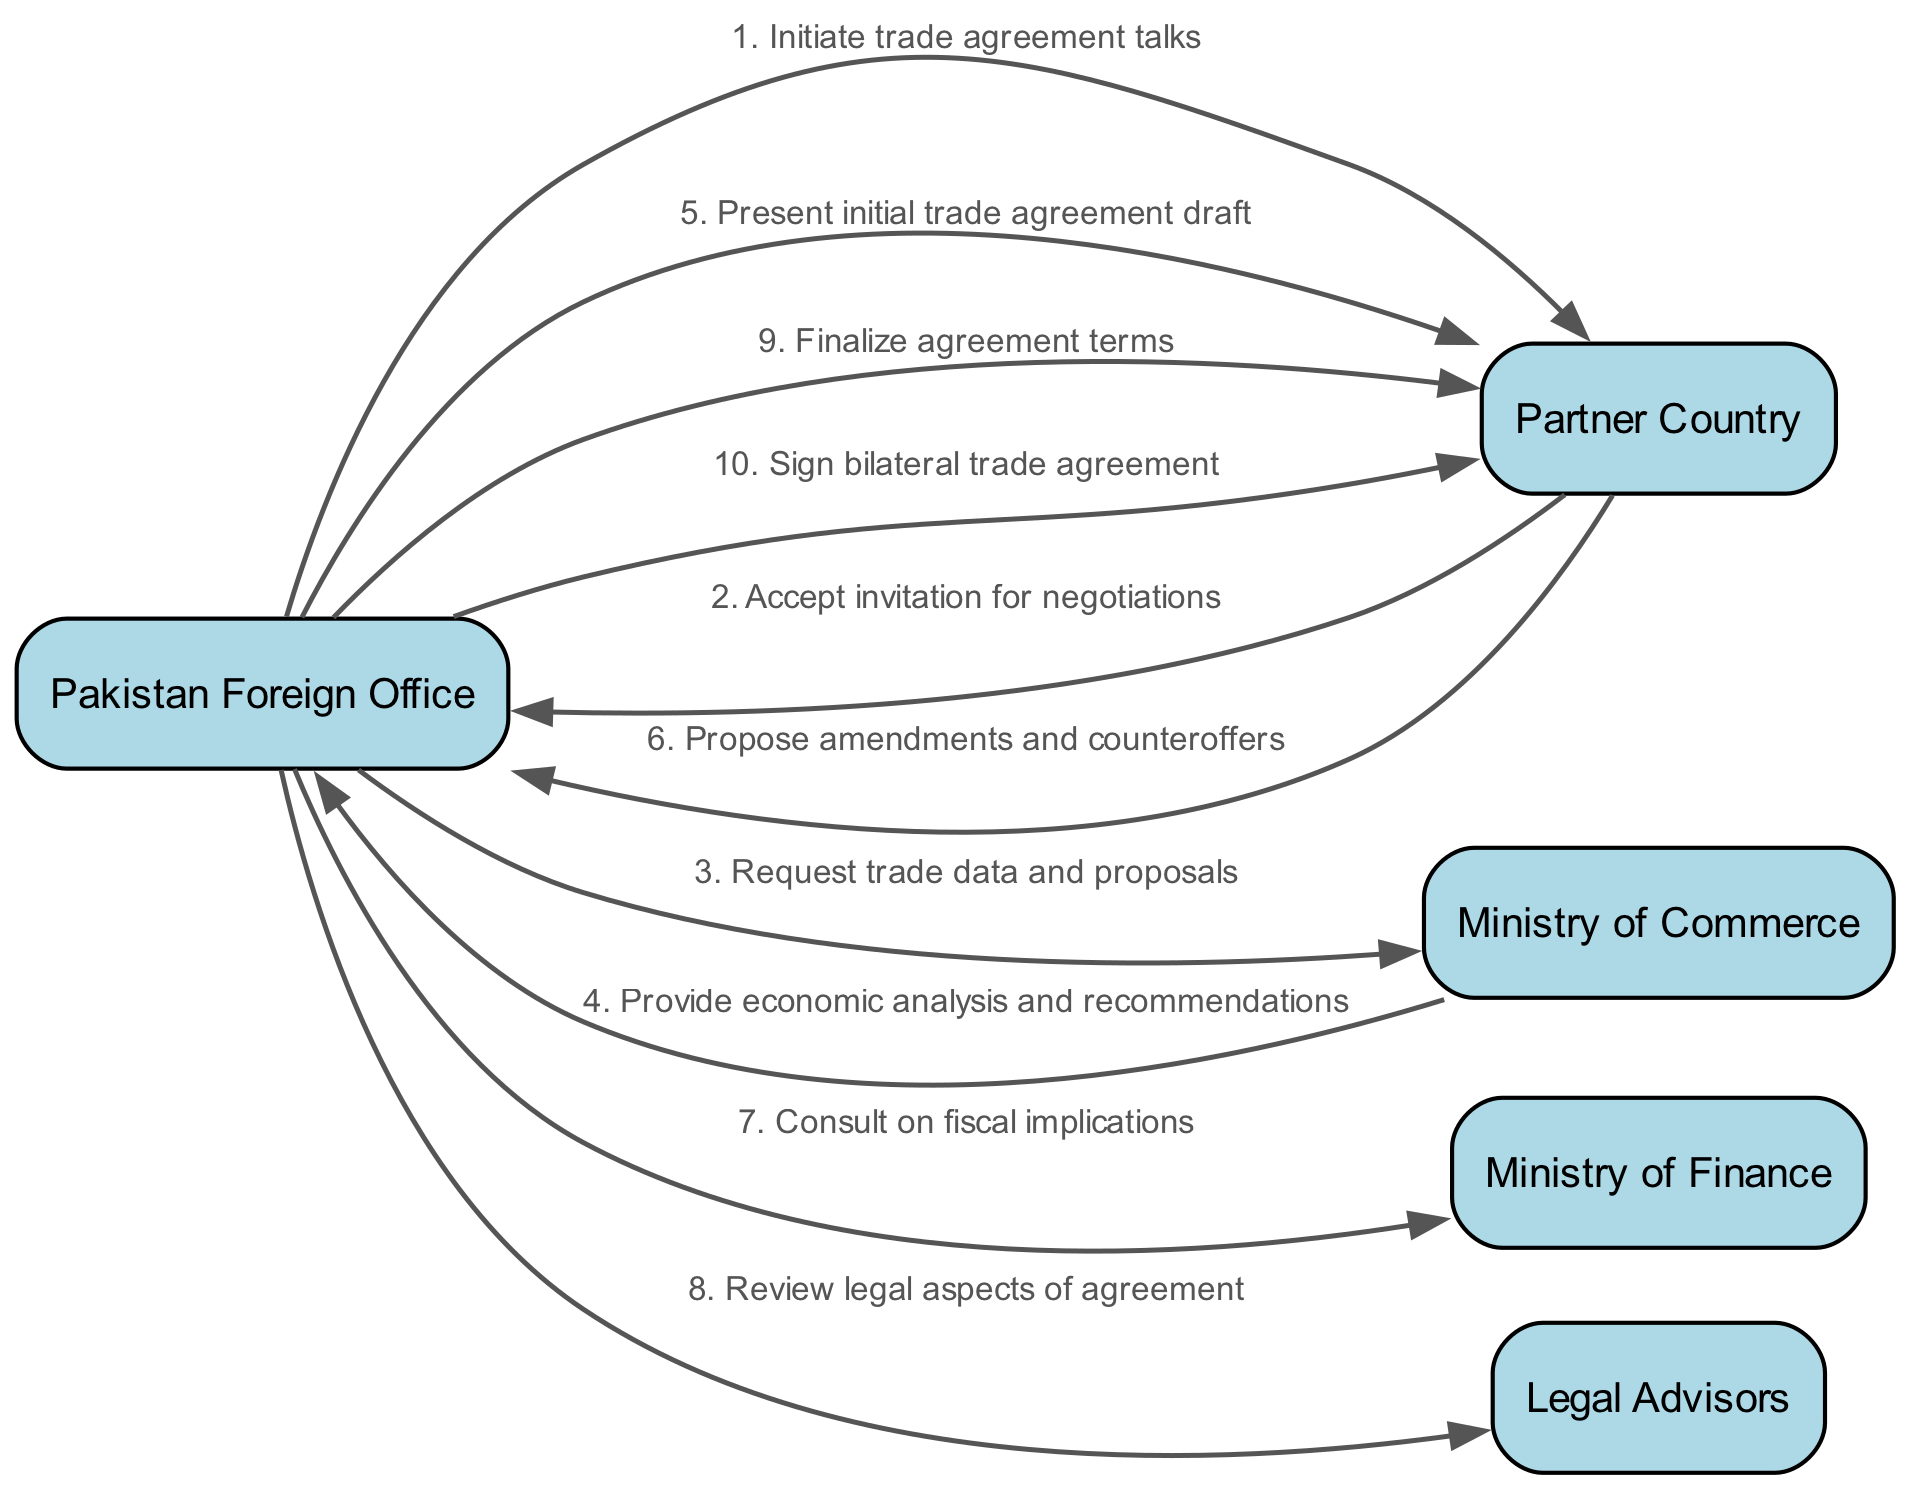What is the first message in the sequence? The first message is from the "Pakistan Foreign Office" to the "Partner Country" with the message "Initiate trade agreement talks".
Answer: Initiate trade agreement talks How many actors are involved in the negotiation process? The diagram lists five distinct actors: Pakistan Foreign Office, Partner Country, Ministry of Commerce, Ministry of Finance, and Legal Advisors.
Answer: Five What is the last message sent in the sequence? The last message is from the "Pakistan Foreign Office" to the "Partner Country", stating "Sign bilateral trade agreement".
Answer: Sign bilateral trade agreement Which actor provides economic analysis and recommendations? The "Ministry of Commerce" is responsible for providing economic analysis and recommendations to the "Pakistan Foreign Office".
Answer: Ministry of Commerce What step involves consulting on fiscal implications? The message in step 7 from the "Pakistan Foreign Office" to the "Ministry of Finance" involves consulting on fiscal implications.
Answer: Consult on fiscal implications What is the relationship between the "Partner Country" and the "Pakistan Foreign Office" after presenting the initial trade agreement draft? After presenting the initial trade agreement draft, the "Partner Country" responds by proposing amendments and counteroffers.
Answer: Propose amendments and counteroffers How many total messages are exchanged between the "Pakistan Foreign Office" and the "Partner Country"? There are five messages exchanged between the "Pakistan Foreign Office" and the "Partner Country".
Answer: Five What do the "Legal Advisors" review in the negotiation process? The "Legal Advisors" are involved in reviewing the legal aspects of the agreement as indicated in the diagram.
Answer: Review legal aspects of agreement 